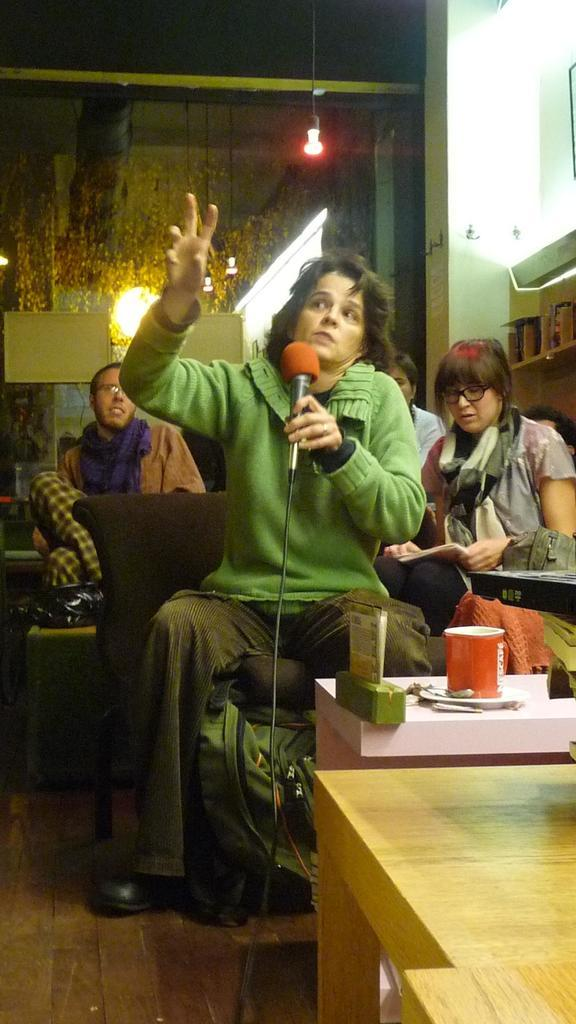What is the woman in the image doing? The woman is sitting in the image. What is the woman holding in the image? The woman is holding a microphone. Can you describe the people behind the woman? There are people behind the woman, but their specific actions or appearances are not mentioned in the facts. What is located behind the woman? There is a wall behind the woman. What is in front of the woman? There is a table in front of the woman. What is on the table? There is a cup on the table. What type of expert is providing a caption for the planes in the image? There are no planes or experts providing captions in the image. 